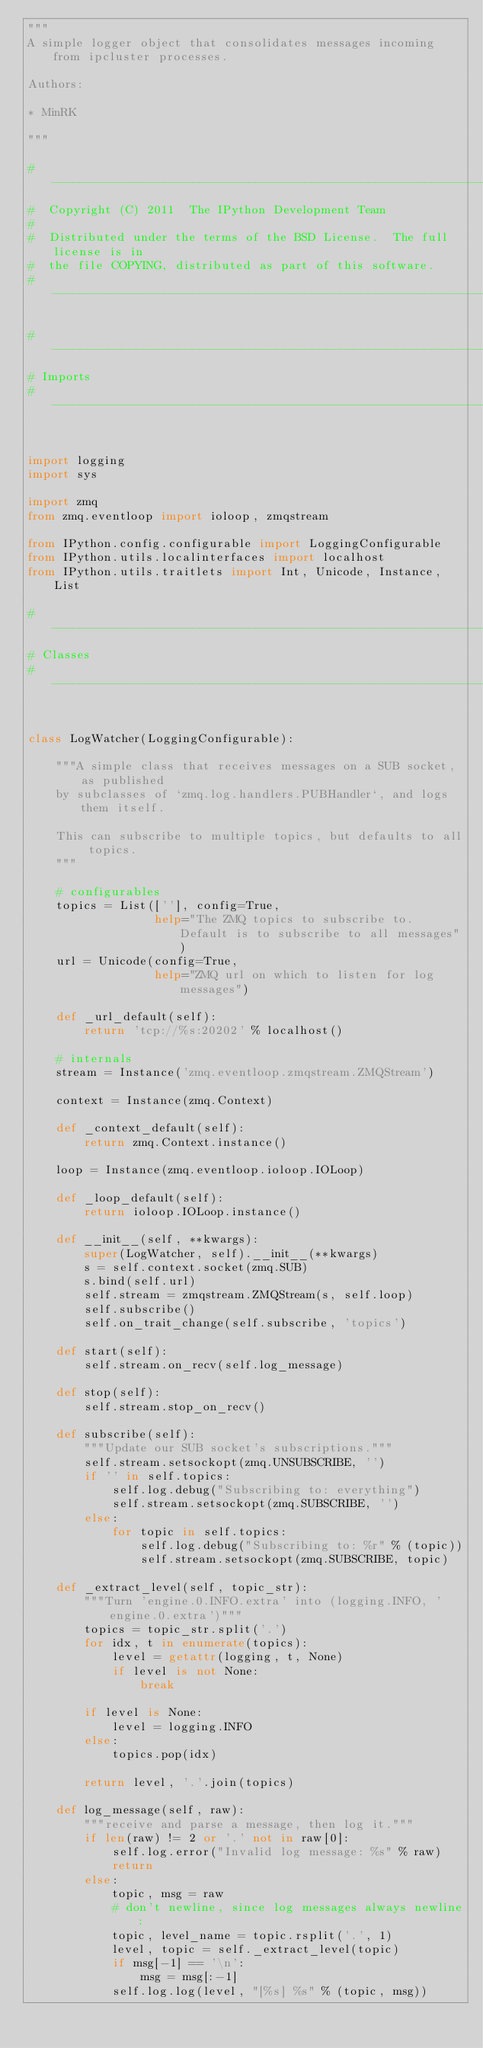<code> <loc_0><loc_0><loc_500><loc_500><_Python_>"""
A simple logger object that consolidates messages incoming from ipcluster processes.

Authors:

* MinRK

"""

#-----------------------------------------------------------------------------
#  Copyright (C) 2011  The IPython Development Team
#
#  Distributed under the terms of the BSD License.  The full license is in
#  the file COPYING, distributed as part of this software.
#-----------------------------------------------------------------------------

#-----------------------------------------------------------------------------
# Imports
#-----------------------------------------------------------------------------


import logging
import sys

import zmq
from zmq.eventloop import ioloop, zmqstream

from IPython.config.configurable import LoggingConfigurable
from IPython.utils.localinterfaces import localhost
from IPython.utils.traitlets import Int, Unicode, Instance, List

#-----------------------------------------------------------------------------
# Classes
#-----------------------------------------------------------------------------


class LogWatcher(LoggingConfigurable):

    """A simple class that receives messages on a SUB socket, as published
    by subclasses of `zmq.log.handlers.PUBHandler`, and logs them itself.

    This can subscribe to multiple topics, but defaults to all topics.
    """

    # configurables
    topics = List([''], config=True,
                  help="The ZMQ topics to subscribe to. Default is to subscribe to all messages")
    url = Unicode(config=True,
                  help="ZMQ url on which to listen for log messages")

    def _url_default(self):
        return 'tcp://%s:20202' % localhost()

    # internals
    stream = Instance('zmq.eventloop.zmqstream.ZMQStream')

    context = Instance(zmq.Context)

    def _context_default(self):
        return zmq.Context.instance()

    loop = Instance(zmq.eventloop.ioloop.IOLoop)

    def _loop_default(self):
        return ioloop.IOLoop.instance()

    def __init__(self, **kwargs):
        super(LogWatcher, self).__init__(**kwargs)
        s = self.context.socket(zmq.SUB)
        s.bind(self.url)
        self.stream = zmqstream.ZMQStream(s, self.loop)
        self.subscribe()
        self.on_trait_change(self.subscribe, 'topics')

    def start(self):
        self.stream.on_recv(self.log_message)

    def stop(self):
        self.stream.stop_on_recv()

    def subscribe(self):
        """Update our SUB socket's subscriptions."""
        self.stream.setsockopt(zmq.UNSUBSCRIBE, '')
        if '' in self.topics:
            self.log.debug("Subscribing to: everything")
            self.stream.setsockopt(zmq.SUBSCRIBE, '')
        else:
            for topic in self.topics:
                self.log.debug("Subscribing to: %r" % (topic))
                self.stream.setsockopt(zmq.SUBSCRIBE, topic)

    def _extract_level(self, topic_str):
        """Turn 'engine.0.INFO.extra' into (logging.INFO, 'engine.0.extra')"""
        topics = topic_str.split('.')
        for idx, t in enumerate(topics):
            level = getattr(logging, t, None)
            if level is not None:
                break

        if level is None:
            level = logging.INFO
        else:
            topics.pop(idx)

        return level, '.'.join(topics)

    def log_message(self, raw):
        """receive and parse a message, then log it."""
        if len(raw) != 2 or '.' not in raw[0]:
            self.log.error("Invalid log message: %s" % raw)
            return
        else:
            topic, msg = raw
            # don't newline, since log messages always newline:
            topic, level_name = topic.rsplit('.', 1)
            level, topic = self._extract_level(topic)
            if msg[-1] == '\n':
                msg = msg[:-1]
            self.log.log(level, "[%s] %s" % (topic, msg))
</code> 